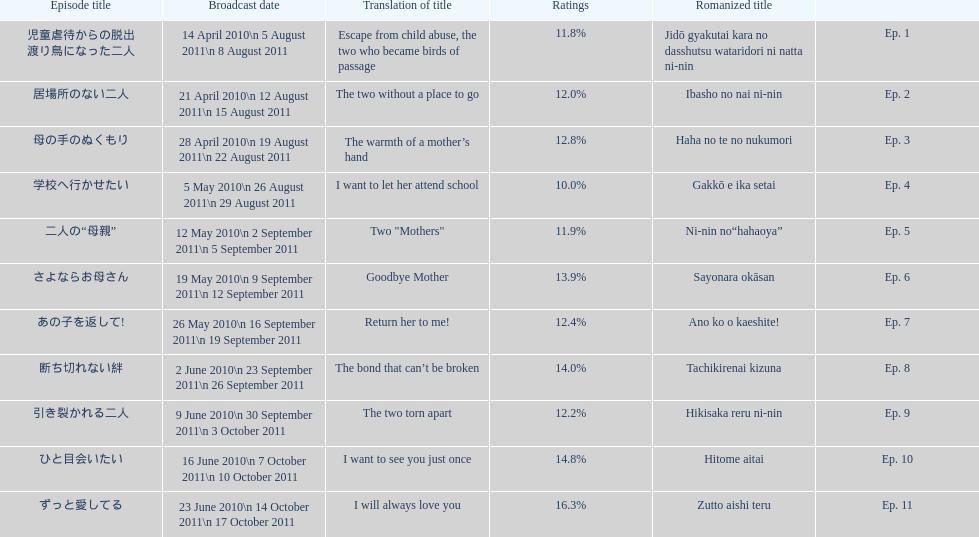What as the percentage total of ratings for episode 8? 14.0%. 